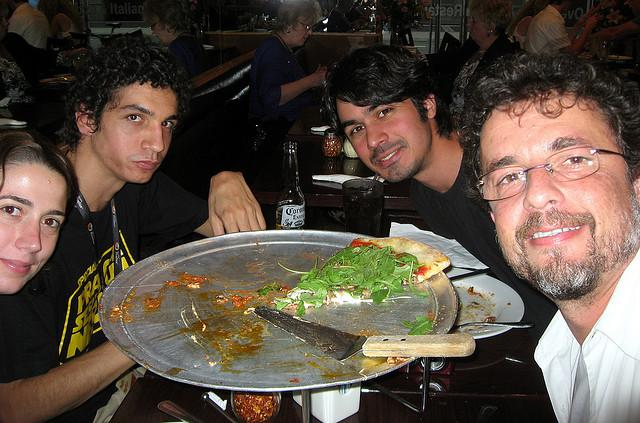What is covering the last slice of pizza available on the tray? Please explain your reasoning. spinach. The last slice of pizza on the tray is covered with spinach leaves. 